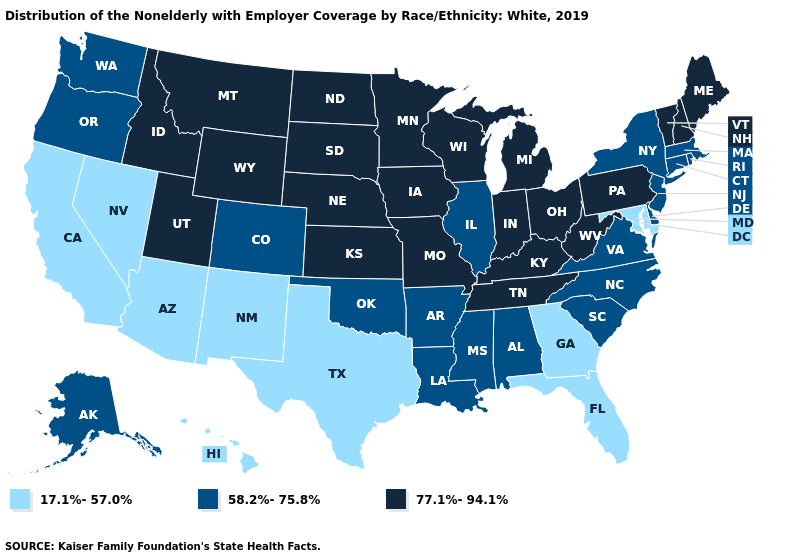Is the legend a continuous bar?
Write a very short answer. No. What is the value of Montana?
Answer briefly. 77.1%-94.1%. What is the value of Nebraska?
Be succinct. 77.1%-94.1%. Does Rhode Island have the highest value in the USA?
Be succinct. No. Name the states that have a value in the range 58.2%-75.8%?
Answer briefly. Alabama, Alaska, Arkansas, Colorado, Connecticut, Delaware, Illinois, Louisiana, Massachusetts, Mississippi, New Jersey, New York, North Carolina, Oklahoma, Oregon, Rhode Island, South Carolina, Virginia, Washington. Does Minnesota have the highest value in the USA?
Keep it brief. Yes. Does Rhode Island have the same value as Alaska?
Quick response, please. Yes. Is the legend a continuous bar?
Write a very short answer. No. What is the value of Nevada?
Give a very brief answer. 17.1%-57.0%. What is the value of Wisconsin?
Quick response, please. 77.1%-94.1%. Does Hawaii have the same value as Virginia?
Concise answer only. No. Does Maine have the highest value in the Northeast?
Be succinct. Yes. Name the states that have a value in the range 58.2%-75.8%?
Concise answer only. Alabama, Alaska, Arkansas, Colorado, Connecticut, Delaware, Illinois, Louisiana, Massachusetts, Mississippi, New Jersey, New York, North Carolina, Oklahoma, Oregon, Rhode Island, South Carolina, Virginia, Washington. What is the value of Montana?
Short answer required. 77.1%-94.1%. What is the lowest value in states that border North Carolina?
Write a very short answer. 17.1%-57.0%. 